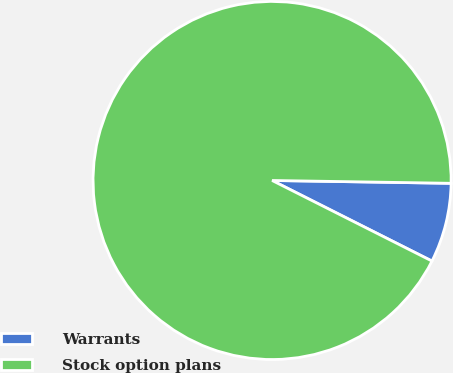Convert chart. <chart><loc_0><loc_0><loc_500><loc_500><pie_chart><fcel>Warrants<fcel>Stock option plans<nl><fcel>7.18%<fcel>92.82%<nl></chart> 